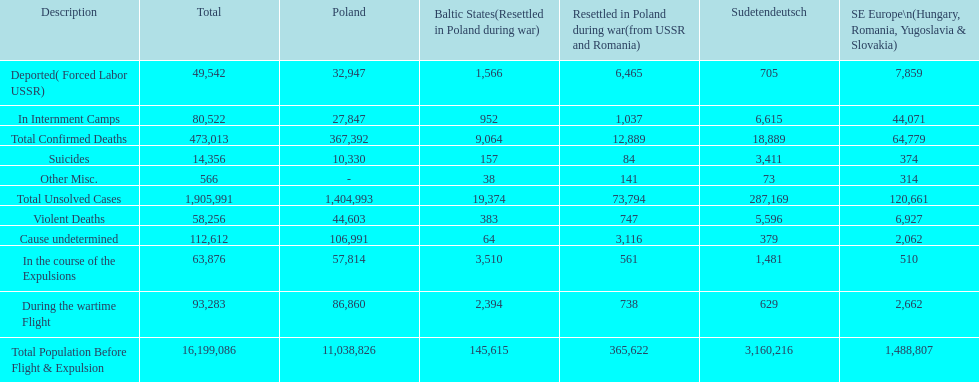What is the total number of violent deaths across all regions? 58,256. 